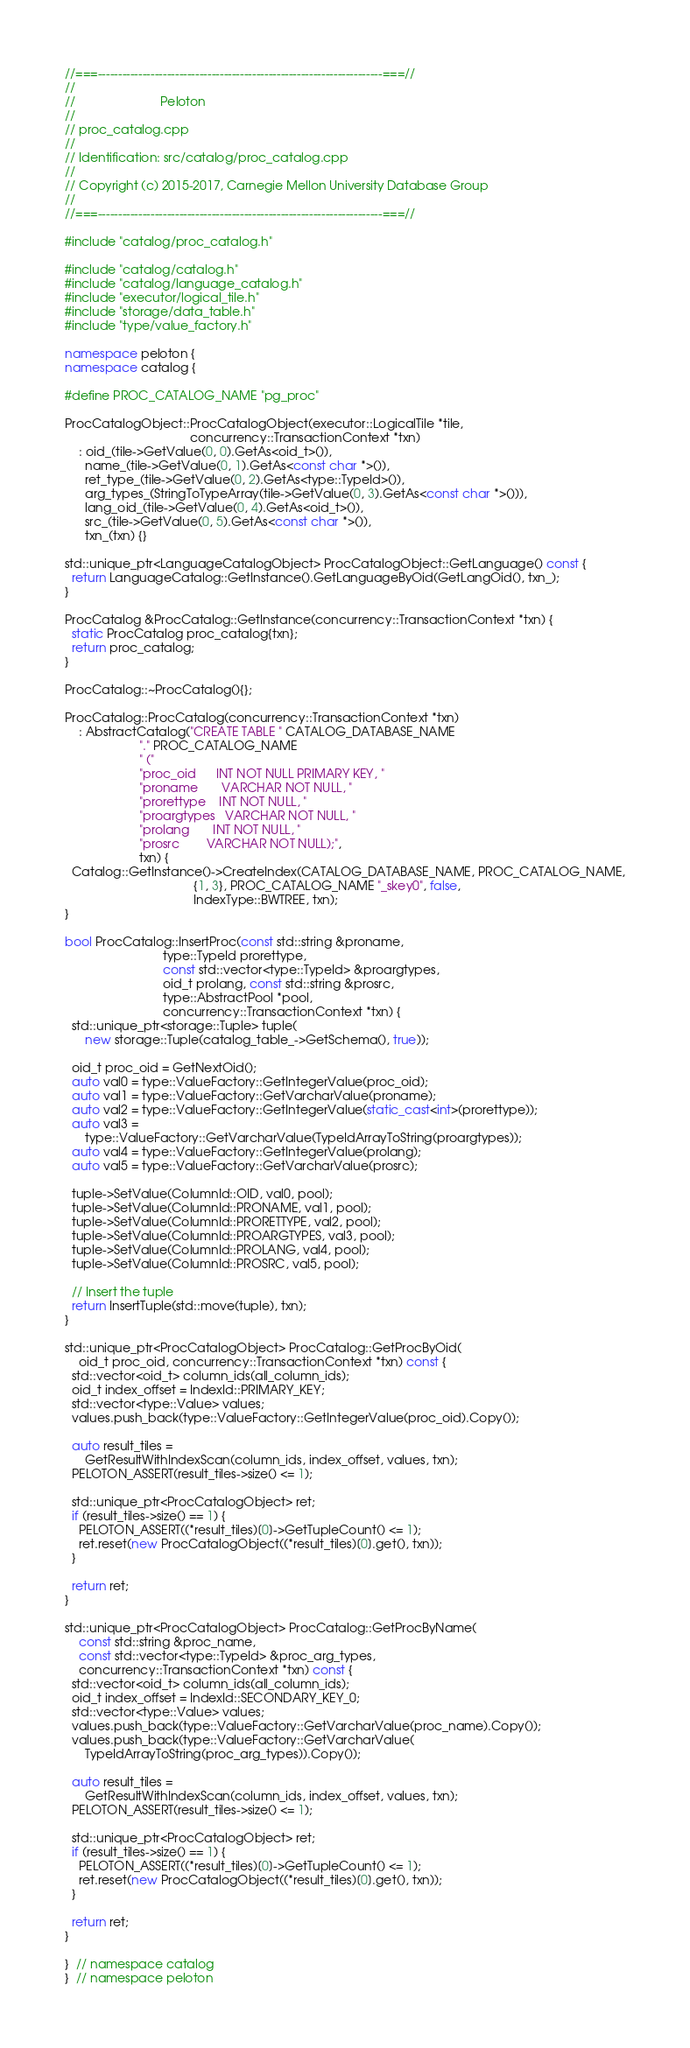<code> <loc_0><loc_0><loc_500><loc_500><_C++_>//===----------------------------------------------------------------------===//
//
//                         Peloton
//
// proc_catalog.cpp
//
// Identification: src/catalog/proc_catalog.cpp
//
// Copyright (c) 2015-2017, Carnegie Mellon University Database Group
//
//===----------------------------------------------------------------------===//

#include "catalog/proc_catalog.h"

#include "catalog/catalog.h"
#include "catalog/language_catalog.h"
#include "executor/logical_tile.h"
#include "storage/data_table.h"
#include "type/value_factory.h"

namespace peloton {
namespace catalog {

#define PROC_CATALOG_NAME "pg_proc"

ProcCatalogObject::ProcCatalogObject(executor::LogicalTile *tile,
                                     concurrency::TransactionContext *txn)
    : oid_(tile->GetValue(0, 0).GetAs<oid_t>()),
      name_(tile->GetValue(0, 1).GetAs<const char *>()),
      ret_type_(tile->GetValue(0, 2).GetAs<type::TypeId>()),
      arg_types_(StringToTypeArray(tile->GetValue(0, 3).GetAs<const char *>())),
      lang_oid_(tile->GetValue(0, 4).GetAs<oid_t>()),
      src_(tile->GetValue(0, 5).GetAs<const char *>()),
      txn_(txn) {}

std::unique_ptr<LanguageCatalogObject> ProcCatalogObject::GetLanguage() const {
  return LanguageCatalog::GetInstance().GetLanguageByOid(GetLangOid(), txn_);
}

ProcCatalog &ProcCatalog::GetInstance(concurrency::TransactionContext *txn) {
  static ProcCatalog proc_catalog{txn};
  return proc_catalog;
}

ProcCatalog::~ProcCatalog(){};

ProcCatalog::ProcCatalog(concurrency::TransactionContext *txn)
    : AbstractCatalog("CREATE TABLE " CATALOG_DATABASE_NAME
                      "." PROC_CATALOG_NAME
                      " ("
                      "proc_oid      INT NOT NULL PRIMARY KEY, "
                      "proname       VARCHAR NOT NULL, "
                      "prorettype    INT NOT NULL, "
                      "proargtypes   VARCHAR NOT NULL, "
                      "prolang       INT NOT NULL, "
                      "prosrc        VARCHAR NOT NULL);",
                      txn) {
  Catalog::GetInstance()->CreateIndex(CATALOG_DATABASE_NAME, PROC_CATALOG_NAME,
                                      {1, 3}, PROC_CATALOG_NAME "_skey0", false,
                                      IndexType::BWTREE, txn);
}

bool ProcCatalog::InsertProc(const std::string &proname,
                             type::TypeId prorettype,
                             const std::vector<type::TypeId> &proargtypes,
                             oid_t prolang, const std::string &prosrc,
                             type::AbstractPool *pool,
                             concurrency::TransactionContext *txn) {
  std::unique_ptr<storage::Tuple> tuple(
      new storage::Tuple(catalog_table_->GetSchema(), true));

  oid_t proc_oid = GetNextOid();
  auto val0 = type::ValueFactory::GetIntegerValue(proc_oid);
  auto val1 = type::ValueFactory::GetVarcharValue(proname);
  auto val2 = type::ValueFactory::GetIntegerValue(static_cast<int>(prorettype));
  auto val3 =
      type::ValueFactory::GetVarcharValue(TypeIdArrayToString(proargtypes));
  auto val4 = type::ValueFactory::GetIntegerValue(prolang);
  auto val5 = type::ValueFactory::GetVarcharValue(prosrc);

  tuple->SetValue(ColumnId::OID, val0, pool);
  tuple->SetValue(ColumnId::PRONAME, val1, pool);
  tuple->SetValue(ColumnId::PRORETTYPE, val2, pool);
  tuple->SetValue(ColumnId::PROARGTYPES, val3, pool);
  tuple->SetValue(ColumnId::PROLANG, val4, pool);
  tuple->SetValue(ColumnId::PROSRC, val5, pool);

  // Insert the tuple
  return InsertTuple(std::move(tuple), txn);
}

std::unique_ptr<ProcCatalogObject> ProcCatalog::GetProcByOid(
    oid_t proc_oid, concurrency::TransactionContext *txn) const {
  std::vector<oid_t> column_ids(all_column_ids);
  oid_t index_offset = IndexId::PRIMARY_KEY;
  std::vector<type::Value> values;
  values.push_back(type::ValueFactory::GetIntegerValue(proc_oid).Copy());

  auto result_tiles =
      GetResultWithIndexScan(column_ids, index_offset, values, txn);
  PELOTON_ASSERT(result_tiles->size() <= 1);

  std::unique_ptr<ProcCatalogObject> ret;
  if (result_tiles->size() == 1) {
    PELOTON_ASSERT((*result_tiles)[0]->GetTupleCount() <= 1);
    ret.reset(new ProcCatalogObject((*result_tiles)[0].get(), txn));
  }

  return ret;
}

std::unique_ptr<ProcCatalogObject> ProcCatalog::GetProcByName(
    const std::string &proc_name,
    const std::vector<type::TypeId> &proc_arg_types,
    concurrency::TransactionContext *txn) const {
  std::vector<oid_t> column_ids(all_column_ids);
  oid_t index_offset = IndexId::SECONDARY_KEY_0;
  std::vector<type::Value> values;
  values.push_back(type::ValueFactory::GetVarcharValue(proc_name).Copy());
  values.push_back(type::ValueFactory::GetVarcharValue(
      TypeIdArrayToString(proc_arg_types)).Copy());

  auto result_tiles =
      GetResultWithIndexScan(column_ids, index_offset, values, txn);
  PELOTON_ASSERT(result_tiles->size() <= 1);

  std::unique_ptr<ProcCatalogObject> ret;
  if (result_tiles->size() == 1) {
    PELOTON_ASSERT((*result_tiles)[0]->GetTupleCount() <= 1);
    ret.reset(new ProcCatalogObject((*result_tiles)[0].get(), txn));
  }

  return ret;
}

}  // namespace catalog
}  // namespace peloton
</code> 